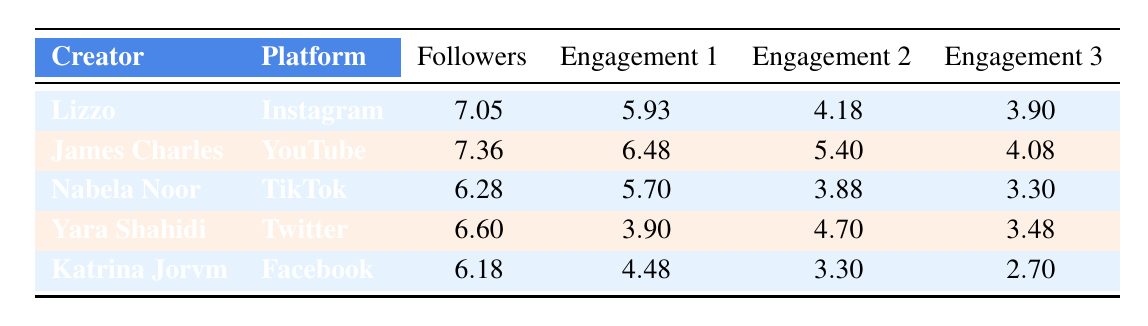What's the highest number of followers among the creators listed? The table shows various creators with their follower counts. By scanning the "Followers" column, the highest value is 7.36, which corresponds to James Charles' 23,100,000 subscribers on YouTube.
Answer: 23,100,000 Which creator has the highest average likes per post/video? The table lists likes for each creator under different platforms. By comparing the values in the "Engagement 1" column, James Charles has the highest value at 250,000 likes per video on YouTube.
Answer: James Charles Is Yara Shahidi's total engagement on Twitter higher than Nabela Noor's on TikTok? Comparing Yara's engagement values (3.90 for retweets, 4.70 for likes, and 3.48 for comments) sums up to about 12.08. Nabela's engagement values (5.70 likes, 3.88 comments and 3.30 shares) sum to about 12.88. Since 12.08 < 12.88, Yara's total engagement is not higher than Nabela's.
Answer: No What is the total engagement score for Lizzo on Instagram? Lizzo's engagement metrics consist of 5.93 (likes), 4.18 (comments), and 3.90 (shares). Adding these values gives us a total engagement score: 5.93 + 4.18 + 3.90 = 14.01.
Answer: 14.01 Does Katrina Jorvm have more followers than Nabela Noor? The "Followers" column shows Katrina has 1,500,000 followers while Nabela has 1,900,000 followers on TikTok. Since 1,500,000 < 1,900,000, Katrina does not have more followers.
Answer: No Which creator has the lowest engagement score in the "Shares" category? Looking at the "Engagement 3" column, Katrina Jorvm has the lowest value of 2.70 shares compared to others, confirming she has the lowest score in that category.
Answer: Katrina Jorvm If we average the likes per post for all creators, what does that yield? Summing the likes per post: 850,000 (Lizzo) + 250,000 (James Charles) + 500,000 (Nabela Noor) + 50,000 (Yara Shahidi) + 30,000 (Katrina Jorvm) = 1,680,000. There are five creators, so the average is 1,680,000 / 5 = 336,000.
Answer: 336,000 Which platform has the highest number of comments per post? From the table, James Charles on YouTube has a high number of comments per video at 12,000 while other creators have lower values in their respective columns. So, YouTube has the highest comments per post metric.
Answer: YouTube What is the difference in follower count between Lizzo and Yara Shahidi? Lizzo has 11,300,000 followers while Yara has 4,000,000. To find the difference, subtract Yara's followers from Lizzo's followers: 11,300,000 - 4,000,000 = 7,300,000.
Answer: 7,300,000 